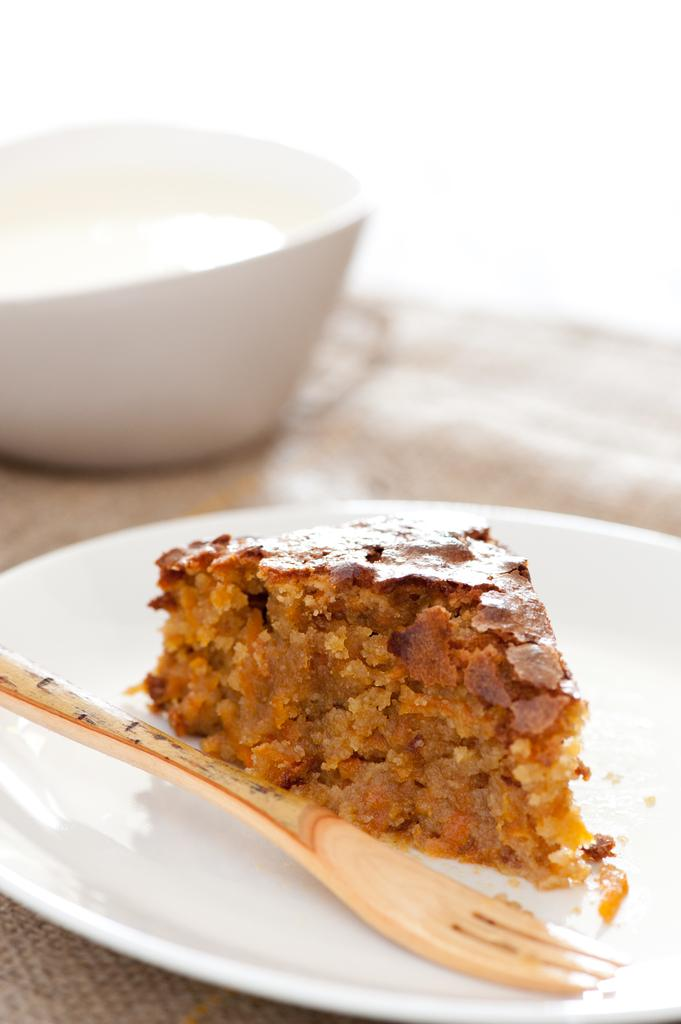What is the main subject of the image? There is a food item in the image. How is the food item presented? The food item is on a white color plate. What utensil is placed with the food item? There is a fork on the plate. What else can be seen in the image besides the food item and plate? There is a cup in the image. Where is the cup located? The cup is on a surface. How does the wind affect the food item in the image? There is no wind present in the image, so it cannot affect the food item. What type of railway is visible in the image? There is no railway present in the image. 